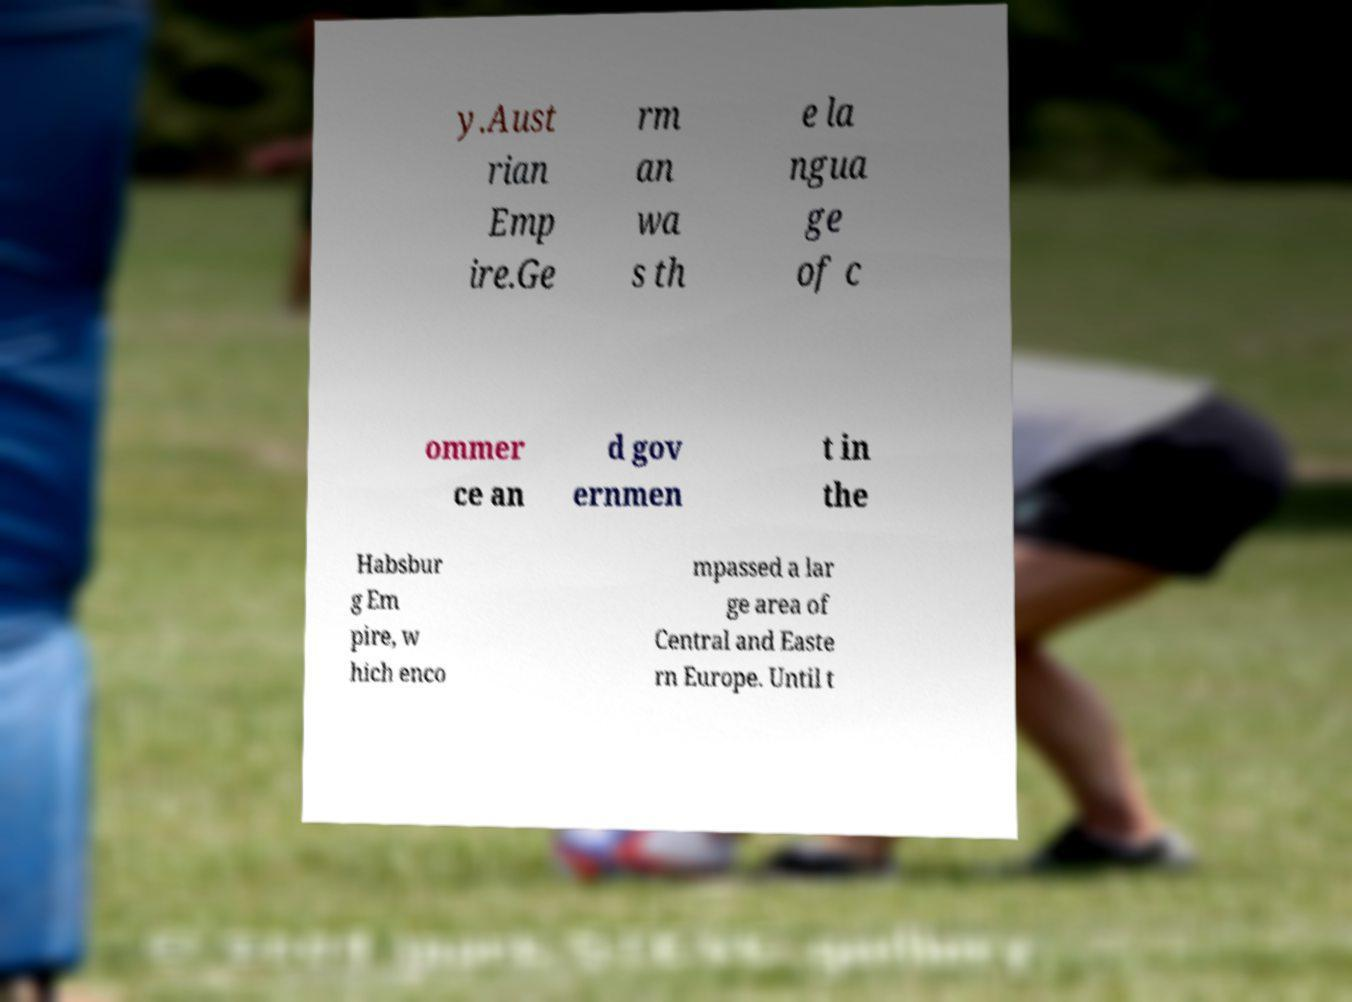Could you extract and type out the text from this image? y.Aust rian Emp ire.Ge rm an wa s th e la ngua ge of c ommer ce an d gov ernmen t in the Habsbur g Em pire, w hich enco mpassed a lar ge area of Central and Easte rn Europe. Until t 